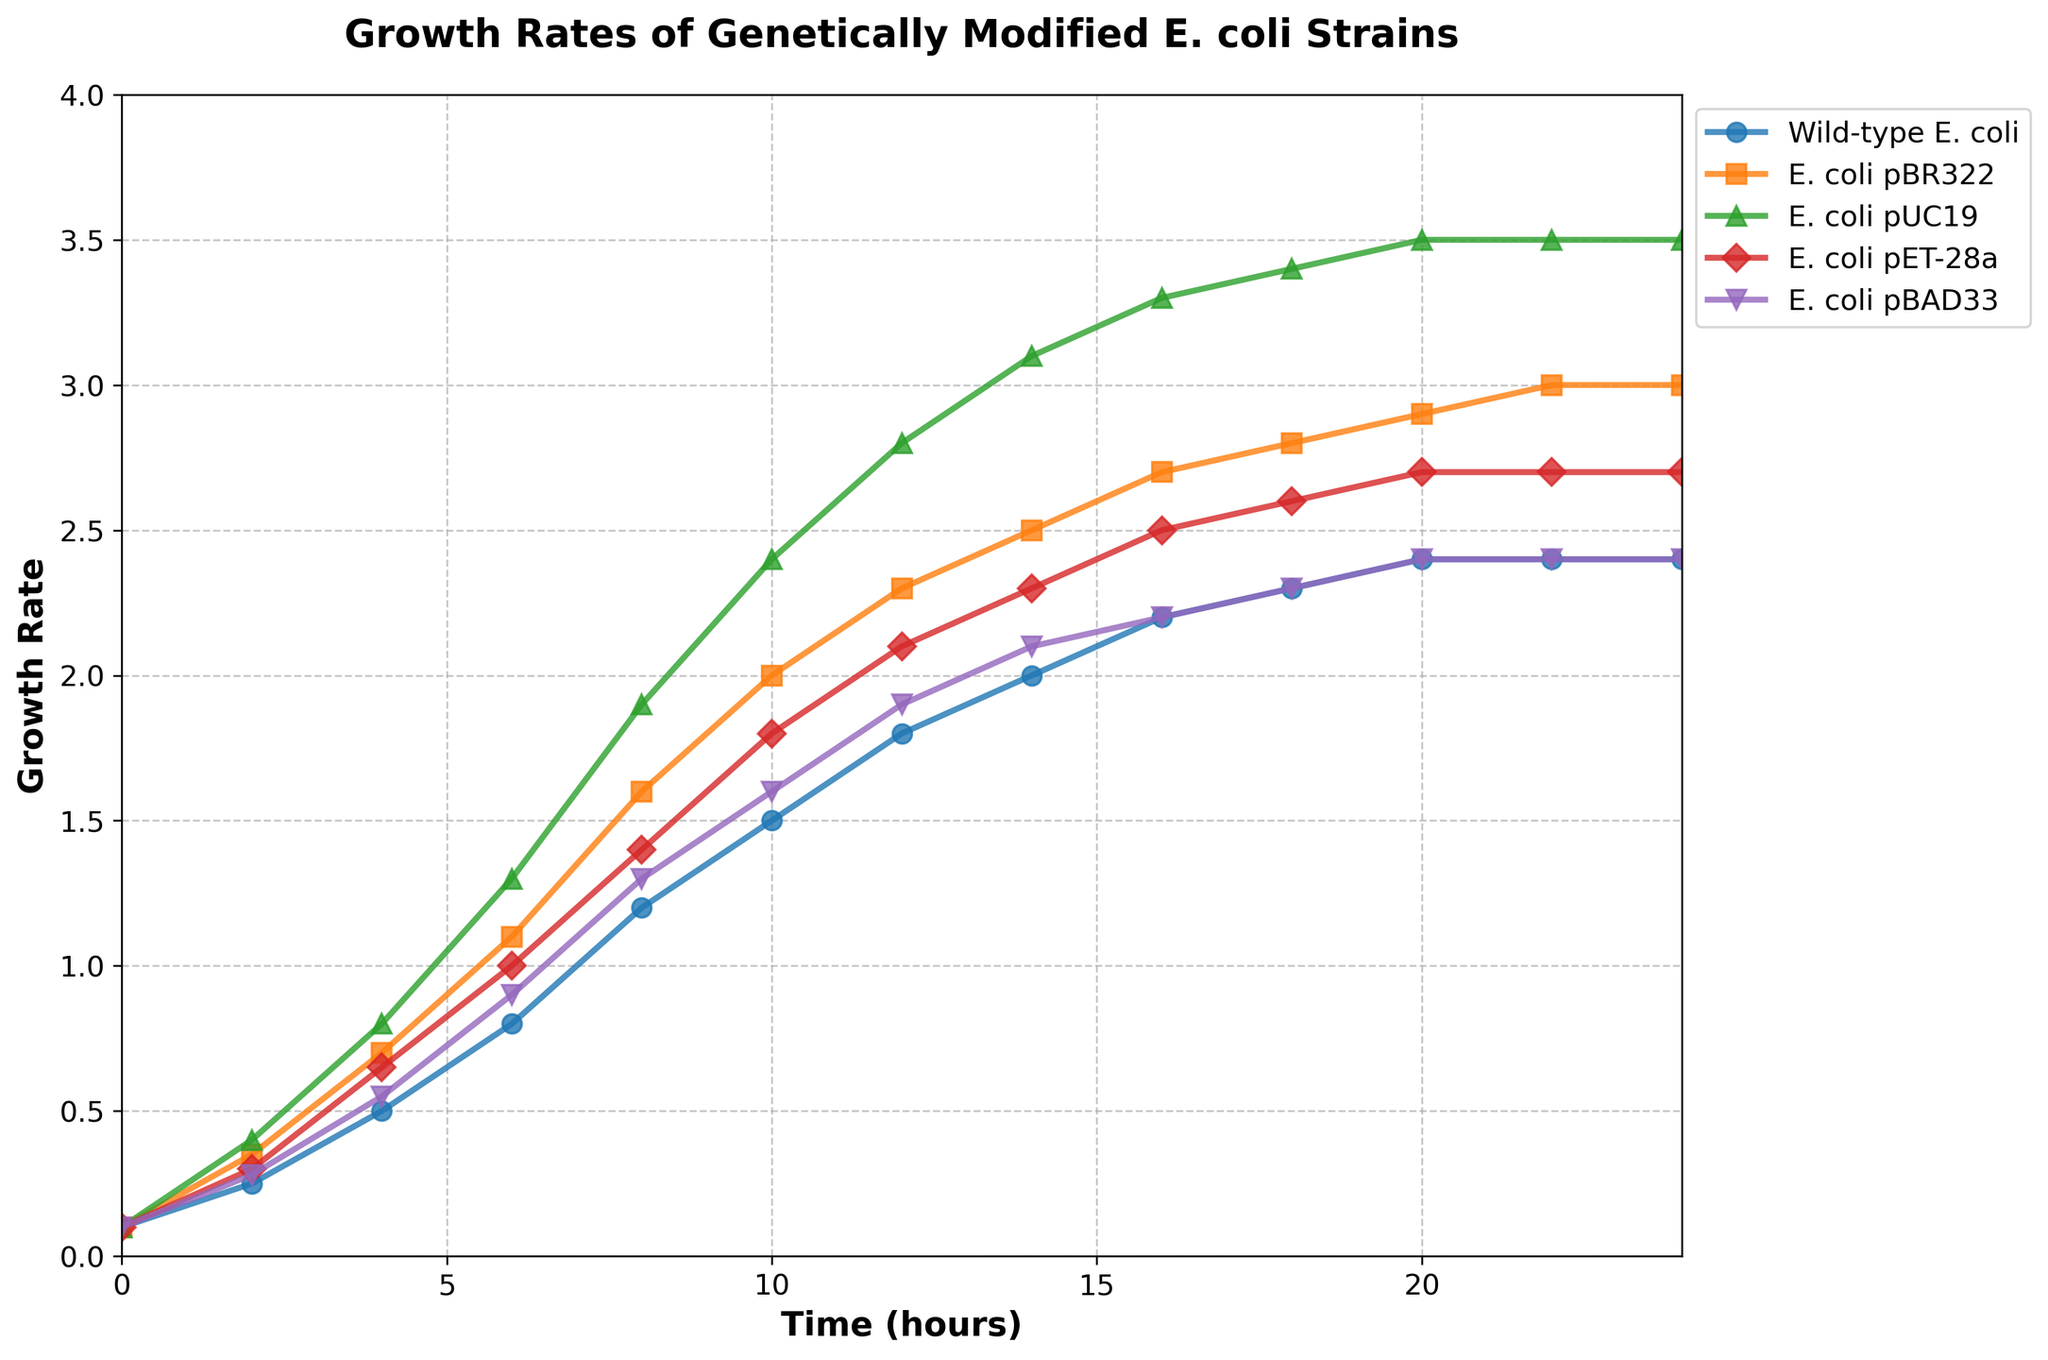What is the growth rate of E. coli pBR322 at 16 hours? Find the point on the E. coli pBR322 line that aligns with 16 hours on the x-axis. The corresponding y-axis value indicates the growth rate.
Answer: 2.7 Which strain has the highest growth rate at 12 hours? Identify the point at 12 hours (x-axis) for each strain and compare their y-axis values. E. coli pUC19 has the highest value.
Answer: E. coli pUC19 How does the growth rate of E. coli pET-28a at 8 hours compare to that of Wild-type E. coli at 14 hours? Locate the growth rate of E. coli pET-28a at 8 hours and Wild-type E. coli at 14 hours on the plot. Compare the y-values.
Answer: Higher What is the average growth rate of Wild-type E. coli between 6 and 12 hours? Sum the growth rates of Wild-type E. coli at 6, 8, 10, and 12 hours: 0.8 + 1.2 + 1.5 + 1.8 = 5.3. Divide by 4.
Answer: 1.325 How much higher is the growth rate of E. coli pUC19 at 18 hours compared to E. coli pBAD33 at 18 hours? Subtract the growth rate of E. coli pBAD33 at 18 hours from the growth rate of E. coli pUC19 at 18 hours: 3.4 - 2.3 = 1.1.
Answer: 1.1 Which strain shows the greatest increase in growth rate between 0 and 4 hours? Calculate the difference in growth rate from 0 to 4 hours for each strain. E. coli pUC19 has the greatest increase: 0.8 - 0.1 = 0.7.
Answer: E. coli pUC19 What trend can be observed for the growth rates of all strains over the 24-hour period? Observe the overall direction of the lines for each strain. All strains show an initial increase in growth rate, which plateaus after 20 hours.
Answer: Increase then plateau At what time do Wild-type E. coli and E. coli pBAD33 have the same growth rate? Identify the first point where the lines for Wild-type E. coli and E. coli pBAD33 intersect.
Answer: 22 hours Between which hours does E. coli pBR322 experience the fastest growth rate increase? Calculate the differences between each time point for E. coli pBR322. The largest increase is between 2 and 4 hours: 0.7 - 0.35 = 0.35.
Answer: 2 and 4 hours Among the strains, which shows the least variability in growth rate from 10 to 24 hours? Examine the trajectories from 10 to 24 hours for each strain. Wild-type E. coli has the least change, hovering around 2.4.
Answer: Wild-type E. coli 